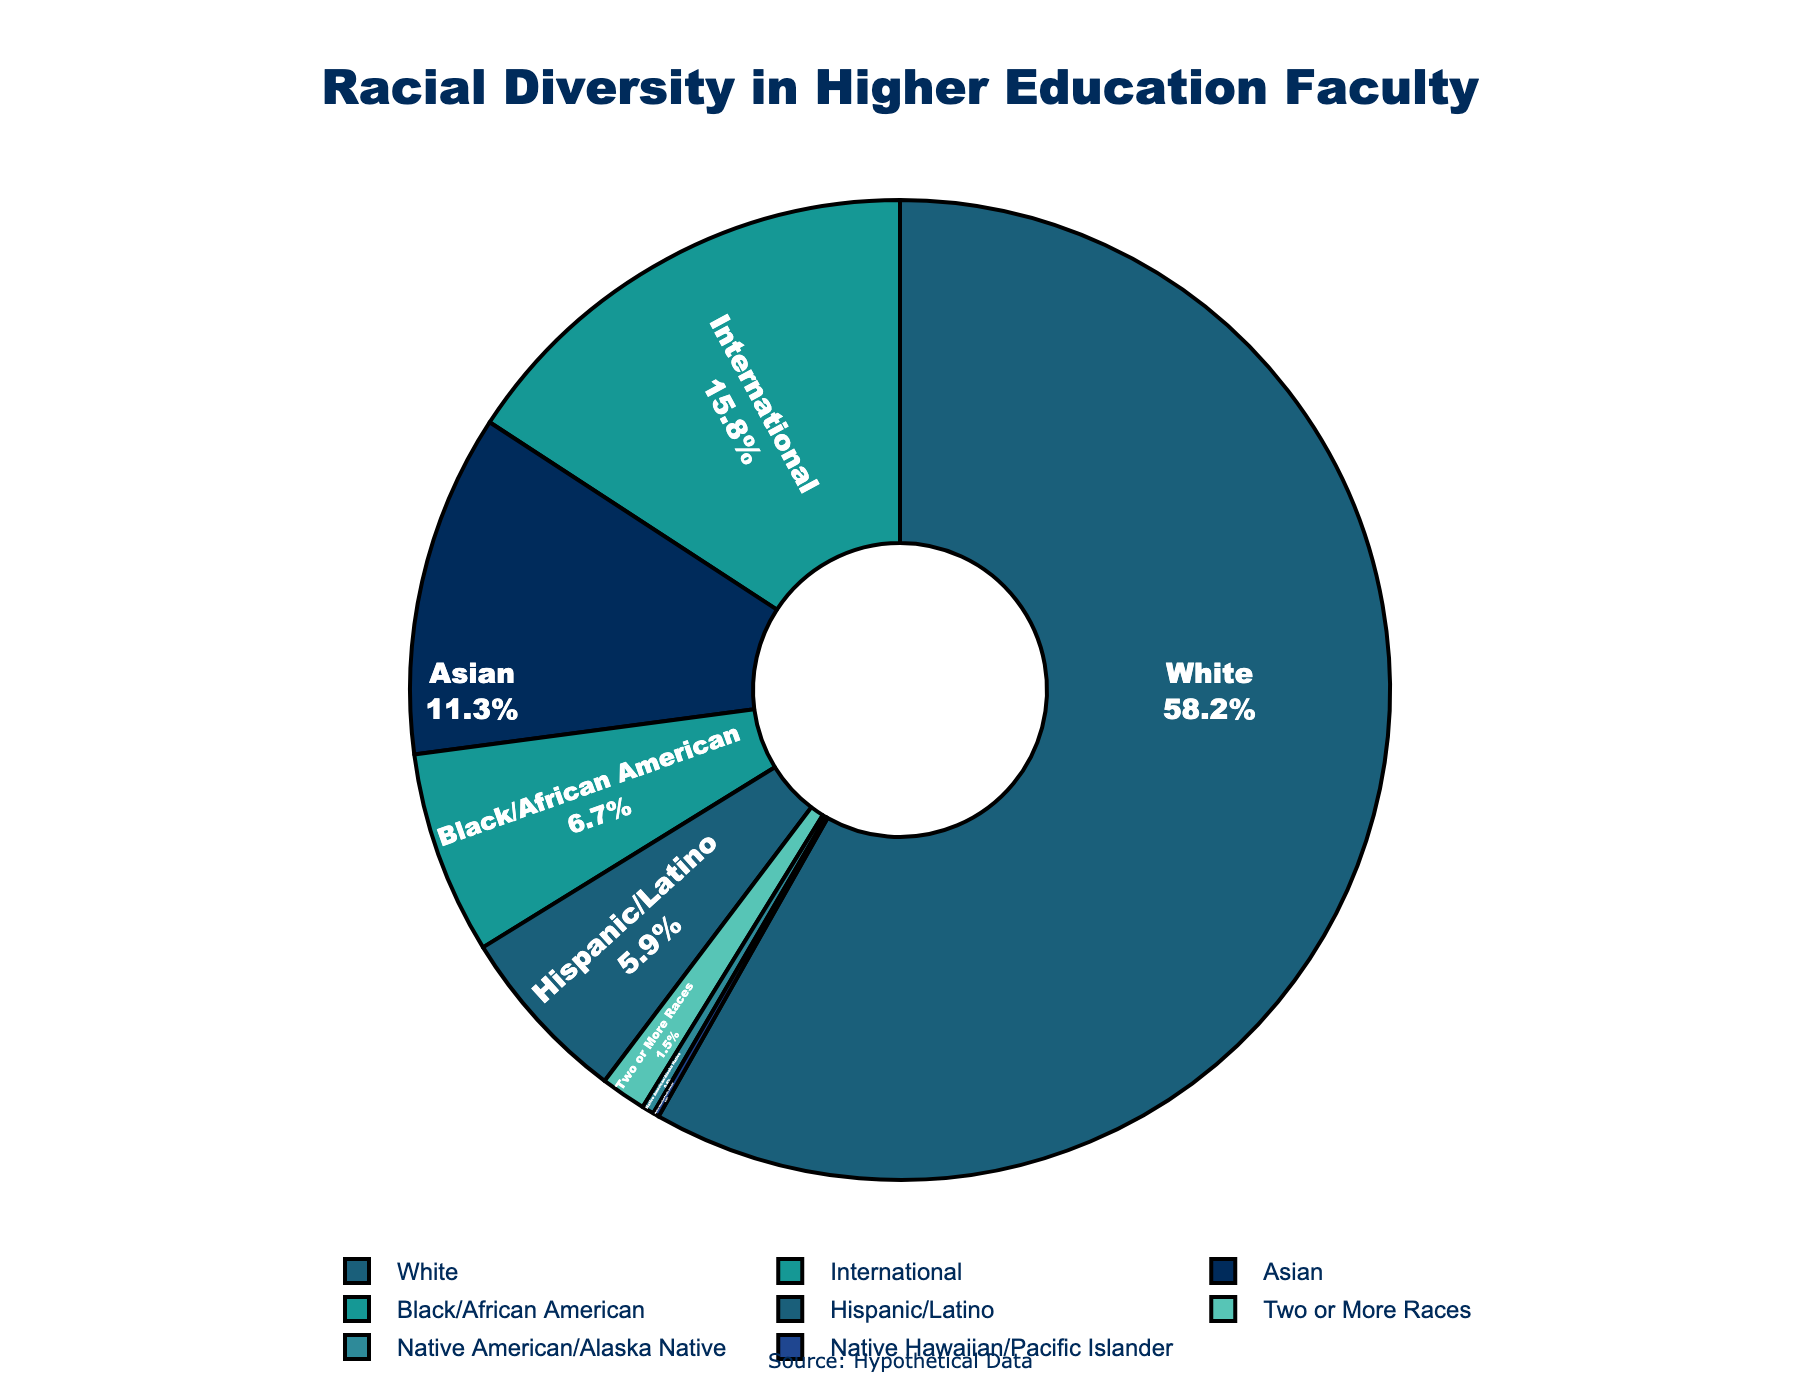What's the largest percentage of any single race/ethnicity group within higher education faculty? The pie chart shows that the White group has the largest representation. To determine this, look at the segment with the highest percentage. The label for the White group is clearly the highest at 58.2%.
Answer: 58.2% What is the combined percentage of Black/African American and Hispanic/Latino faculty? According to the pie chart, the percentage for Black/African American faculty is 6.7% and for Hispanic/Latino faculty is 5.9%. Adding these together, 6.7% + 5.9% results in a total of 12.6%.
Answer: 12.6% Which group has the smallest representation among higher education faculty? The pie chart shows that the Native Hawaiian/Pacific Islander group has the smallest segment. This is confirmed by the value of 0.2% shown on the pie chart.
Answer: Native Hawaiian/Pacific Islander How much larger in percentage is the representation of Asian faculty compared to Hispanic/Latino faculty? The pie chart shows Asian faculty at 11.3% and Hispanic/Latino faculty at 5.9%. To find the difference, subtract 5.9 from 11.3, which gives 5.4. So, Asian faculty's representation is 5.4% larger.
Answer: 5.4% What is the total percentage representation for all minority groups combined, excluding White and International categories? Excluding the White and International categories, add the percentages: Black/African American (6.7) + Hispanic/Latino (5.9) + Asian (11.3) + Native American/Alaska Native (0.4) + Native Hawaiian/Pacific Islander (0.2) + Two or More Races (1.5). The total is 26.0%.
Answer: 26.0% Which racial/ethnic group has a representation closest to 5%? The pie chart shows that Hispanic/Latino faculty have a representation of 5.9%, which is the closest to 5%.
Answer: Hispanic/Latino What is the approximate ratio of International faculty to Native American/Alaska Native faculty? The pie chart shows International faculty at 15.8% and Native American/Alaska Native faculty at 0.4%. To find the ratio, divide 15.8 by 0.4, which gives approximately 39.5.
Answer: 39.5 How many groups have a representation percentage of less than 2%? The pie chart segments labeled with representations less than 2% are Native American/Alaska Native (0.4%), Native Hawaiian/Pacific Islander (0.2%), and Two or More Races (1.5%). That's a total of 3 groups.
Answer: 3 What is the difference in percentage between the highest and lowest represented groups? The highest is White with 58.2% and the lowest is Native Hawaiian/Pacific Islander with 0.2%. The difference is 58.2% - 0.2% = 58.0%.
Answer: 58.0% 